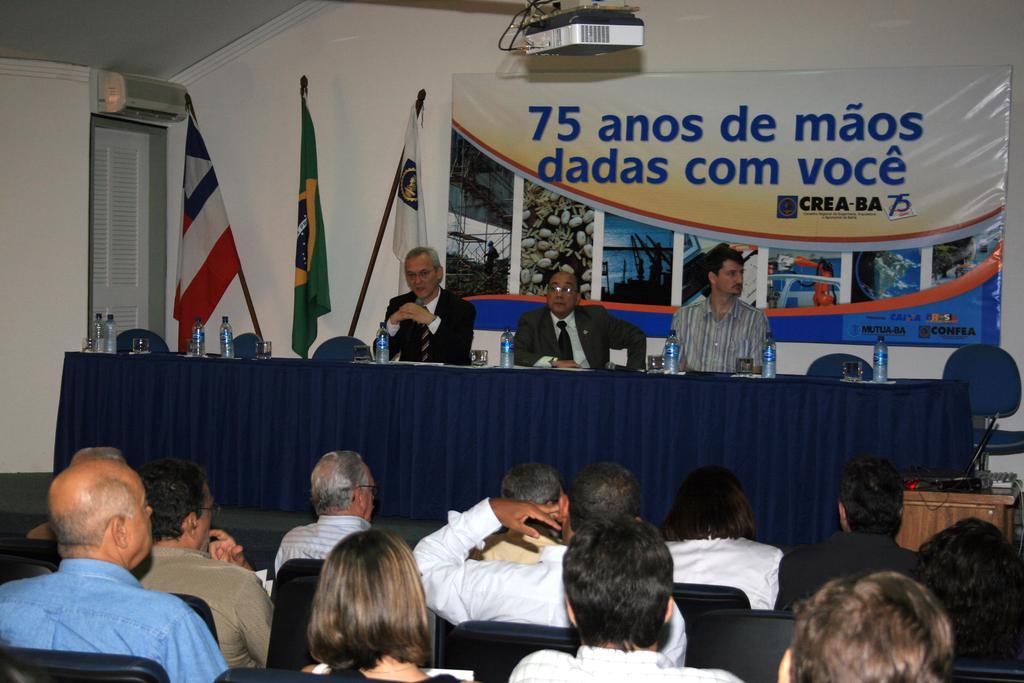In one or two sentences, can you explain what this image depicts? in this image the big room is there in this room there are many people they are sitting on the chair and three people they are sitting in front of the table and some bottles are there on the table the back ground is different and in this room some things are there and three flags are there. 